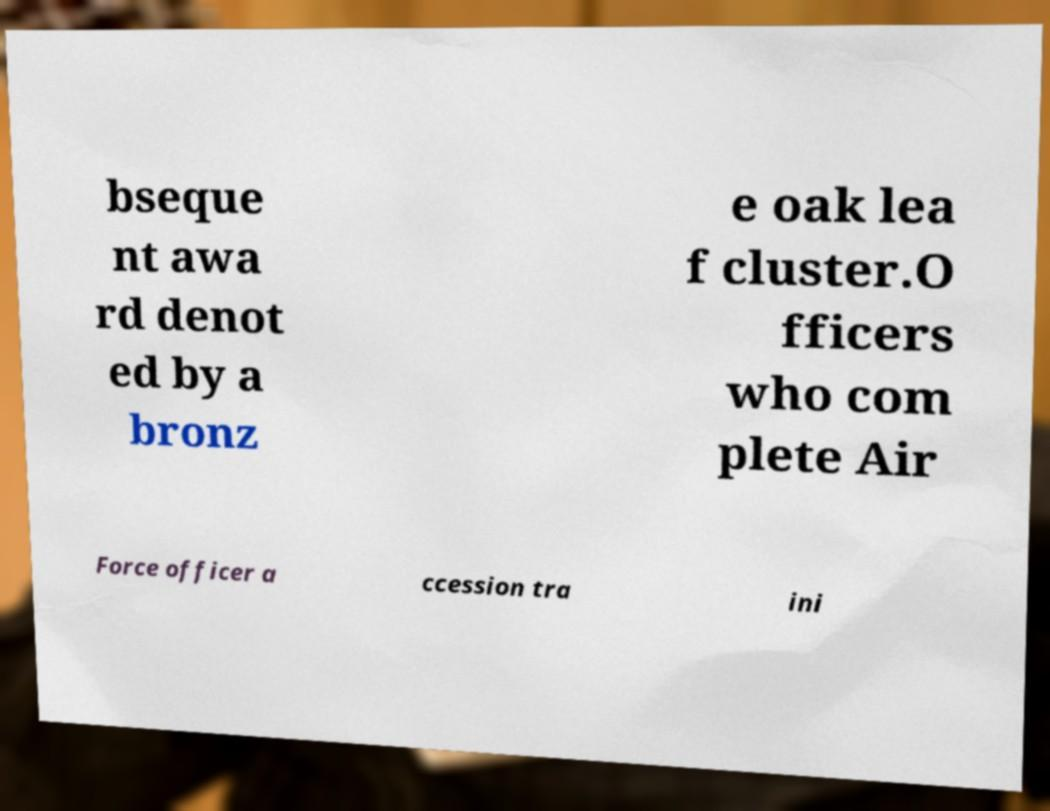I need the written content from this picture converted into text. Can you do that? bseque nt awa rd denot ed by a bronz e oak lea f cluster.O fficers who com plete Air Force officer a ccession tra ini 